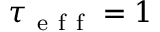<formula> <loc_0><loc_0><loc_500><loc_500>\tau _ { e f f } = 1</formula> 